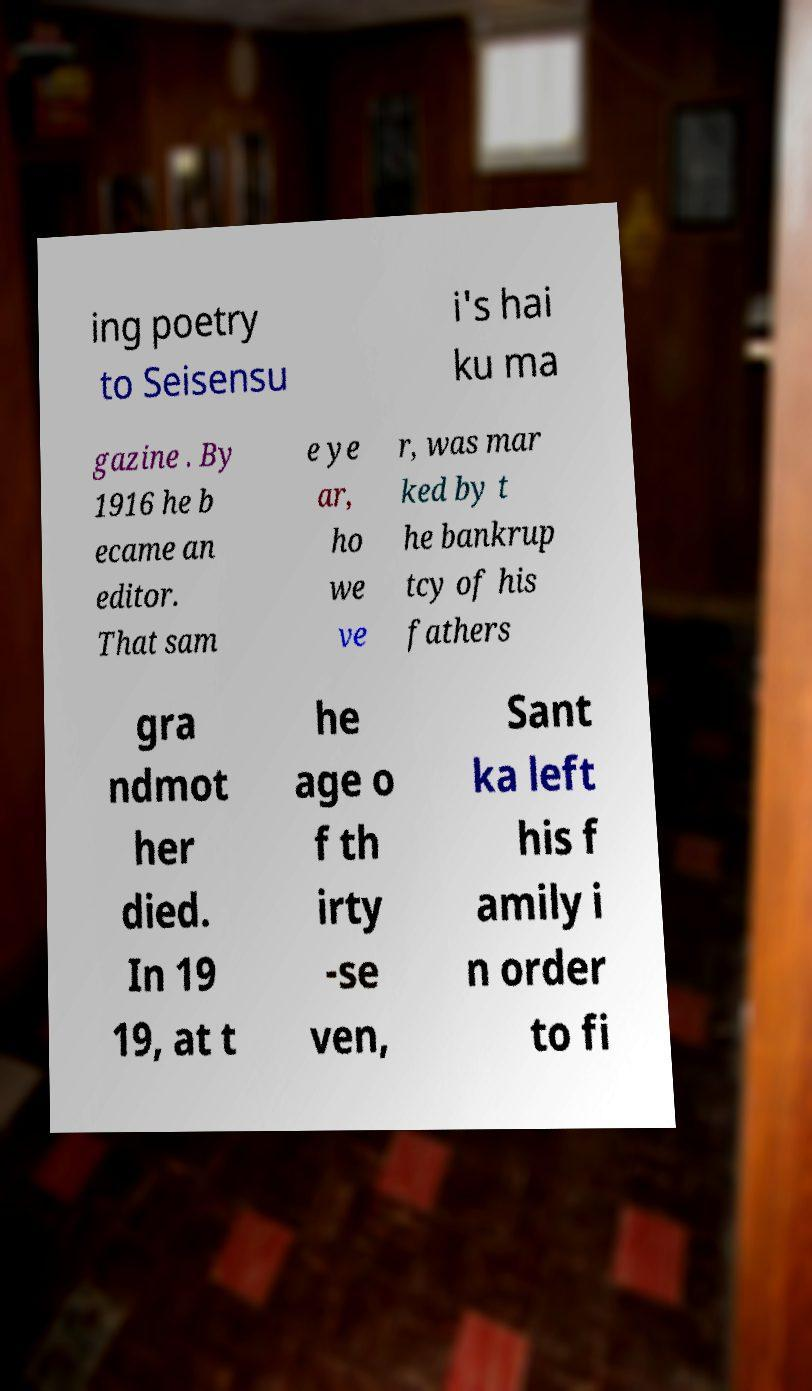Please read and relay the text visible in this image. What does it say? ing poetry to Seisensu i's hai ku ma gazine . By 1916 he b ecame an editor. That sam e ye ar, ho we ve r, was mar ked by t he bankrup tcy of his fathers gra ndmot her died. In 19 19, at t he age o f th irty -se ven, Sant ka left his f amily i n order to fi 